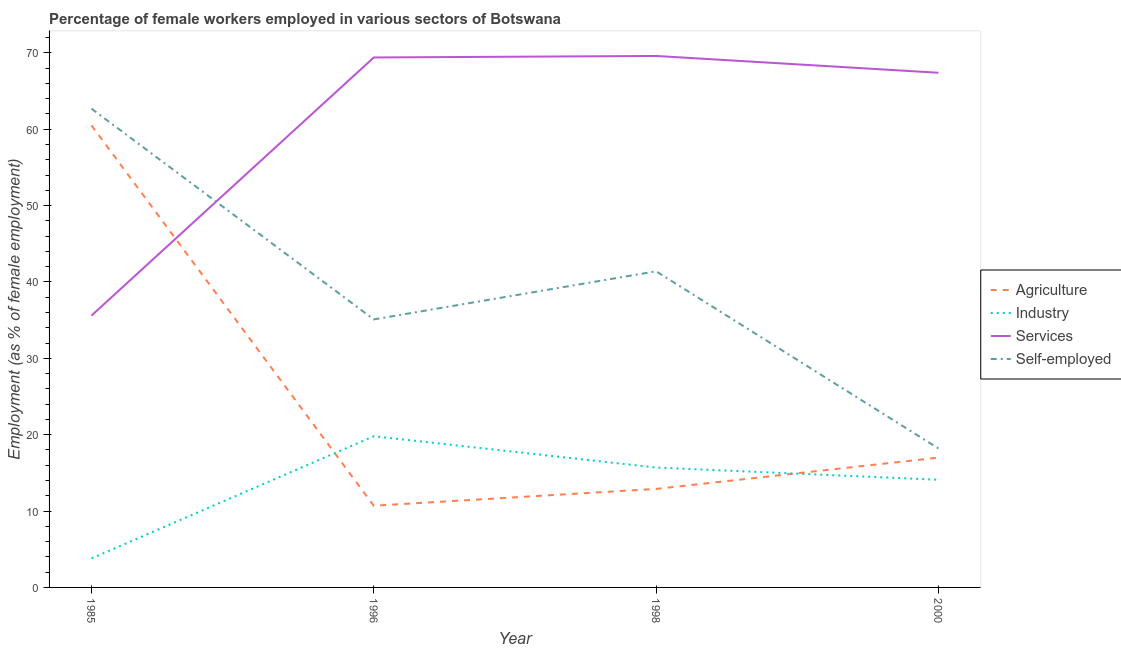Across all years, what is the maximum percentage of female workers in services?
Provide a short and direct response. 69.6. Across all years, what is the minimum percentage of female workers in agriculture?
Your answer should be compact. 10.7. In which year was the percentage of self employed female workers minimum?
Ensure brevity in your answer.  2000. What is the total percentage of female workers in industry in the graph?
Your answer should be very brief. 53.4. What is the difference between the percentage of female workers in industry in 1985 and that in 1996?
Provide a succinct answer. -16. What is the difference between the percentage of female workers in agriculture in 2000 and the percentage of self employed female workers in 1998?
Make the answer very short. -24.4. What is the average percentage of female workers in industry per year?
Your answer should be compact. 13.35. In the year 1985, what is the difference between the percentage of female workers in agriculture and percentage of female workers in industry?
Give a very brief answer. 56.7. What is the ratio of the percentage of female workers in services in 1996 to that in 1998?
Give a very brief answer. 1. Is the percentage of self employed female workers in 1998 less than that in 2000?
Provide a short and direct response. No. What is the difference between the highest and the second highest percentage of female workers in services?
Provide a succinct answer. 0.2. What is the difference between the highest and the lowest percentage of self employed female workers?
Offer a very short reply. 44.5. In how many years, is the percentage of self employed female workers greater than the average percentage of self employed female workers taken over all years?
Your response must be concise. 2. Is the sum of the percentage of female workers in services in 1985 and 2000 greater than the maximum percentage of female workers in agriculture across all years?
Make the answer very short. Yes. Is it the case that in every year, the sum of the percentage of female workers in industry and percentage of female workers in agriculture is greater than the sum of percentage of female workers in services and percentage of self employed female workers?
Offer a very short reply. No. Is it the case that in every year, the sum of the percentage of female workers in agriculture and percentage of female workers in industry is greater than the percentage of female workers in services?
Offer a very short reply. No. Does the percentage of female workers in industry monotonically increase over the years?
Keep it short and to the point. No. Is the percentage of female workers in services strictly greater than the percentage of self employed female workers over the years?
Offer a very short reply. No. How many lines are there?
Your response must be concise. 4. How many years are there in the graph?
Keep it short and to the point. 4. What is the difference between two consecutive major ticks on the Y-axis?
Provide a short and direct response. 10. Are the values on the major ticks of Y-axis written in scientific E-notation?
Ensure brevity in your answer.  No. Does the graph contain any zero values?
Give a very brief answer. No. Does the graph contain grids?
Make the answer very short. No. Where does the legend appear in the graph?
Provide a short and direct response. Center right. What is the title of the graph?
Offer a terse response. Percentage of female workers employed in various sectors of Botswana. Does "Payroll services" appear as one of the legend labels in the graph?
Give a very brief answer. No. What is the label or title of the X-axis?
Your answer should be compact. Year. What is the label or title of the Y-axis?
Provide a succinct answer. Employment (as % of female employment). What is the Employment (as % of female employment) of Agriculture in 1985?
Provide a succinct answer. 60.5. What is the Employment (as % of female employment) in Industry in 1985?
Give a very brief answer. 3.8. What is the Employment (as % of female employment) of Services in 1985?
Ensure brevity in your answer.  35.6. What is the Employment (as % of female employment) of Self-employed in 1985?
Provide a succinct answer. 62.7. What is the Employment (as % of female employment) of Agriculture in 1996?
Give a very brief answer. 10.7. What is the Employment (as % of female employment) of Industry in 1996?
Keep it short and to the point. 19.8. What is the Employment (as % of female employment) in Services in 1996?
Give a very brief answer. 69.4. What is the Employment (as % of female employment) in Self-employed in 1996?
Give a very brief answer. 35.1. What is the Employment (as % of female employment) in Agriculture in 1998?
Make the answer very short. 12.9. What is the Employment (as % of female employment) in Industry in 1998?
Keep it short and to the point. 15.7. What is the Employment (as % of female employment) of Services in 1998?
Give a very brief answer. 69.6. What is the Employment (as % of female employment) of Self-employed in 1998?
Your response must be concise. 41.4. What is the Employment (as % of female employment) of Industry in 2000?
Ensure brevity in your answer.  14.1. What is the Employment (as % of female employment) of Services in 2000?
Offer a terse response. 67.4. What is the Employment (as % of female employment) in Self-employed in 2000?
Offer a very short reply. 18.2. Across all years, what is the maximum Employment (as % of female employment) in Agriculture?
Your answer should be very brief. 60.5. Across all years, what is the maximum Employment (as % of female employment) of Industry?
Make the answer very short. 19.8. Across all years, what is the maximum Employment (as % of female employment) of Services?
Your response must be concise. 69.6. Across all years, what is the maximum Employment (as % of female employment) of Self-employed?
Provide a succinct answer. 62.7. Across all years, what is the minimum Employment (as % of female employment) of Agriculture?
Offer a very short reply. 10.7. Across all years, what is the minimum Employment (as % of female employment) of Industry?
Offer a terse response. 3.8. Across all years, what is the minimum Employment (as % of female employment) in Services?
Ensure brevity in your answer.  35.6. Across all years, what is the minimum Employment (as % of female employment) of Self-employed?
Provide a short and direct response. 18.2. What is the total Employment (as % of female employment) of Agriculture in the graph?
Your answer should be very brief. 101.1. What is the total Employment (as % of female employment) in Industry in the graph?
Make the answer very short. 53.4. What is the total Employment (as % of female employment) in Services in the graph?
Offer a very short reply. 242. What is the total Employment (as % of female employment) in Self-employed in the graph?
Your response must be concise. 157.4. What is the difference between the Employment (as % of female employment) in Agriculture in 1985 and that in 1996?
Make the answer very short. 49.8. What is the difference between the Employment (as % of female employment) of Services in 1985 and that in 1996?
Provide a short and direct response. -33.8. What is the difference between the Employment (as % of female employment) of Self-employed in 1985 and that in 1996?
Give a very brief answer. 27.6. What is the difference between the Employment (as % of female employment) of Agriculture in 1985 and that in 1998?
Offer a terse response. 47.6. What is the difference between the Employment (as % of female employment) of Services in 1985 and that in 1998?
Your response must be concise. -34. What is the difference between the Employment (as % of female employment) of Self-employed in 1985 and that in 1998?
Offer a terse response. 21.3. What is the difference between the Employment (as % of female employment) in Agriculture in 1985 and that in 2000?
Provide a short and direct response. 43.5. What is the difference between the Employment (as % of female employment) of Services in 1985 and that in 2000?
Your answer should be compact. -31.8. What is the difference between the Employment (as % of female employment) of Self-employed in 1985 and that in 2000?
Offer a terse response. 44.5. What is the difference between the Employment (as % of female employment) in Agriculture in 1996 and that in 1998?
Offer a terse response. -2.2. What is the difference between the Employment (as % of female employment) in Self-employed in 1996 and that in 1998?
Offer a very short reply. -6.3. What is the difference between the Employment (as % of female employment) in Agriculture in 1996 and that in 2000?
Offer a very short reply. -6.3. What is the difference between the Employment (as % of female employment) in Industry in 1996 and that in 2000?
Your answer should be compact. 5.7. What is the difference between the Employment (as % of female employment) of Services in 1998 and that in 2000?
Provide a succinct answer. 2.2. What is the difference between the Employment (as % of female employment) of Self-employed in 1998 and that in 2000?
Give a very brief answer. 23.2. What is the difference between the Employment (as % of female employment) of Agriculture in 1985 and the Employment (as % of female employment) of Industry in 1996?
Make the answer very short. 40.7. What is the difference between the Employment (as % of female employment) in Agriculture in 1985 and the Employment (as % of female employment) in Services in 1996?
Offer a terse response. -8.9. What is the difference between the Employment (as % of female employment) of Agriculture in 1985 and the Employment (as % of female employment) of Self-employed in 1996?
Give a very brief answer. 25.4. What is the difference between the Employment (as % of female employment) of Industry in 1985 and the Employment (as % of female employment) of Services in 1996?
Your response must be concise. -65.6. What is the difference between the Employment (as % of female employment) in Industry in 1985 and the Employment (as % of female employment) in Self-employed in 1996?
Your answer should be very brief. -31.3. What is the difference between the Employment (as % of female employment) in Services in 1985 and the Employment (as % of female employment) in Self-employed in 1996?
Give a very brief answer. 0.5. What is the difference between the Employment (as % of female employment) in Agriculture in 1985 and the Employment (as % of female employment) in Industry in 1998?
Ensure brevity in your answer.  44.8. What is the difference between the Employment (as % of female employment) in Agriculture in 1985 and the Employment (as % of female employment) in Services in 1998?
Offer a terse response. -9.1. What is the difference between the Employment (as % of female employment) in Agriculture in 1985 and the Employment (as % of female employment) in Self-employed in 1998?
Give a very brief answer. 19.1. What is the difference between the Employment (as % of female employment) in Industry in 1985 and the Employment (as % of female employment) in Services in 1998?
Provide a succinct answer. -65.8. What is the difference between the Employment (as % of female employment) of Industry in 1985 and the Employment (as % of female employment) of Self-employed in 1998?
Provide a short and direct response. -37.6. What is the difference between the Employment (as % of female employment) in Services in 1985 and the Employment (as % of female employment) in Self-employed in 1998?
Offer a very short reply. -5.8. What is the difference between the Employment (as % of female employment) of Agriculture in 1985 and the Employment (as % of female employment) of Industry in 2000?
Offer a very short reply. 46.4. What is the difference between the Employment (as % of female employment) of Agriculture in 1985 and the Employment (as % of female employment) of Self-employed in 2000?
Keep it short and to the point. 42.3. What is the difference between the Employment (as % of female employment) in Industry in 1985 and the Employment (as % of female employment) in Services in 2000?
Keep it short and to the point. -63.6. What is the difference between the Employment (as % of female employment) of Industry in 1985 and the Employment (as % of female employment) of Self-employed in 2000?
Give a very brief answer. -14.4. What is the difference between the Employment (as % of female employment) in Services in 1985 and the Employment (as % of female employment) in Self-employed in 2000?
Provide a short and direct response. 17.4. What is the difference between the Employment (as % of female employment) of Agriculture in 1996 and the Employment (as % of female employment) of Industry in 1998?
Give a very brief answer. -5. What is the difference between the Employment (as % of female employment) in Agriculture in 1996 and the Employment (as % of female employment) in Services in 1998?
Provide a short and direct response. -58.9. What is the difference between the Employment (as % of female employment) in Agriculture in 1996 and the Employment (as % of female employment) in Self-employed in 1998?
Make the answer very short. -30.7. What is the difference between the Employment (as % of female employment) in Industry in 1996 and the Employment (as % of female employment) in Services in 1998?
Offer a terse response. -49.8. What is the difference between the Employment (as % of female employment) of Industry in 1996 and the Employment (as % of female employment) of Self-employed in 1998?
Provide a succinct answer. -21.6. What is the difference between the Employment (as % of female employment) in Services in 1996 and the Employment (as % of female employment) in Self-employed in 1998?
Your answer should be compact. 28. What is the difference between the Employment (as % of female employment) in Agriculture in 1996 and the Employment (as % of female employment) in Services in 2000?
Provide a succinct answer. -56.7. What is the difference between the Employment (as % of female employment) of Industry in 1996 and the Employment (as % of female employment) of Services in 2000?
Ensure brevity in your answer.  -47.6. What is the difference between the Employment (as % of female employment) in Industry in 1996 and the Employment (as % of female employment) in Self-employed in 2000?
Offer a very short reply. 1.6. What is the difference between the Employment (as % of female employment) of Services in 1996 and the Employment (as % of female employment) of Self-employed in 2000?
Your answer should be very brief. 51.2. What is the difference between the Employment (as % of female employment) in Agriculture in 1998 and the Employment (as % of female employment) in Services in 2000?
Make the answer very short. -54.5. What is the difference between the Employment (as % of female employment) in Industry in 1998 and the Employment (as % of female employment) in Services in 2000?
Your answer should be compact. -51.7. What is the difference between the Employment (as % of female employment) in Services in 1998 and the Employment (as % of female employment) in Self-employed in 2000?
Make the answer very short. 51.4. What is the average Employment (as % of female employment) of Agriculture per year?
Make the answer very short. 25.27. What is the average Employment (as % of female employment) of Industry per year?
Ensure brevity in your answer.  13.35. What is the average Employment (as % of female employment) of Services per year?
Ensure brevity in your answer.  60.5. What is the average Employment (as % of female employment) of Self-employed per year?
Provide a succinct answer. 39.35. In the year 1985, what is the difference between the Employment (as % of female employment) in Agriculture and Employment (as % of female employment) in Industry?
Offer a very short reply. 56.7. In the year 1985, what is the difference between the Employment (as % of female employment) in Agriculture and Employment (as % of female employment) in Services?
Offer a very short reply. 24.9. In the year 1985, what is the difference between the Employment (as % of female employment) of Industry and Employment (as % of female employment) of Services?
Offer a very short reply. -31.8. In the year 1985, what is the difference between the Employment (as % of female employment) of Industry and Employment (as % of female employment) of Self-employed?
Offer a very short reply. -58.9. In the year 1985, what is the difference between the Employment (as % of female employment) of Services and Employment (as % of female employment) of Self-employed?
Offer a terse response. -27.1. In the year 1996, what is the difference between the Employment (as % of female employment) of Agriculture and Employment (as % of female employment) of Industry?
Provide a succinct answer. -9.1. In the year 1996, what is the difference between the Employment (as % of female employment) of Agriculture and Employment (as % of female employment) of Services?
Your response must be concise. -58.7. In the year 1996, what is the difference between the Employment (as % of female employment) in Agriculture and Employment (as % of female employment) in Self-employed?
Your response must be concise. -24.4. In the year 1996, what is the difference between the Employment (as % of female employment) in Industry and Employment (as % of female employment) in Services?
Offer a very short reply. -49.6. In the year 1996, what is the difference between the Employment (as % of female employment) in Industry and Employment (as % of female employment) in Self-employed?
Your response must be concise. -15.3. In the year 1996, what is the difference between the Employment (as % of female employment) in Services and Employment (as % of female employment) in Self-employed?
Offer a very short reply. 34.3. In the year 1998, what is the difference between the Employment (as % of female employment) in Agriculture and Employment (as % of female employment) in Industry?
Give a very brief answer. -2.8. In the year 1998, what is the difference between the Employment (as % of female employment) of Agriculture and Employment (as % of female employment) of Services?
Offer a very short reply. -56.7. In the year 1998, what is the difference between the Employment (as % of female employment) in Agriculture and Employment (as % of female employment) in Self-employed?
Ensure brevity in your answer.  -28.5. In the year 1998, what is the difference between the Employment (as % of female employment) of Industry and Employment (as % of female employment) of Services?
Give a very brief answer. -53.9. In the year 1998, what is the difference between the Employment (as % of female employment) of Industry and Employment (as % of female employment) of Self-employed?
Your answer should be compact. -25.7. In the year 1998, what is the difference between the Employment (as % of female employment) in Services and Employment (as % of female employment) in Self-employed?
Ensure brevity in your answer.  28.2. In the year 2000, what is the difference between the Employment (as % of female employment) in Agriculture and Employment (as % of female employment) in Industry?
Provide a short and direct response. 2.9. In the year 2000, what is the difference between the Employment (as % of female employment) of Agriculture and Employment (as % of female employment) of Services?
Your response must be concise. -50.4. In the year 2000, what is the difference between the Employment (as % of female employment) in Industry and Employment (as % of female employment) in Services?
Offer a terse response. -53.3. In the year 2000, what is the difference between the Employment (as % of female employment) in Services and Employment (as % of female employment) in Self-employed?
Your answer should be very brief. 49.2. What is the ratio of the Employment (as % of female employment) of Agriculture in 1985 to that in 1996?
Offer a terse response. 5.65. What is the ratio of the Employment (as % of female employment) in Industry in 1985 to that in 1996?
Ensure brevity in your answer.  0.19. What is the ratio of the Employment (as % of female employment) in Services in 1985 to that in 1996?
Keep it short and to the point. 0.51. What is the ratio of the Employment (as % of female employment) in Self-employed in 1985 to that in 1996?
Ensure brevity in your answer.  1.79. What is the ratio of the Employment (as % of female employment) of Agriculture in 1985 to that in 1998?
Give a very brief answer. 4.69. What is the ratio of the Employment (as % of female employment) in Industry in 1985 to that in 1998?
Offer a very short reply. 0.24. What is the ratio of the Employment (as % of female employment) of Services in 1985 to that in 1998?
Provide a short and direct response. 0.51. What is the ratio of the Employment (as % of female employment) of Self-employed in 1985 to that in 1998?
Give a very brief answer. 1.51. What is the ratio of the Employment (as % of female employment) in Agriculture in 1985 to that in 2000?
Your answer should be compact. 3.56. What is the ratio of the Employment (as % of female employment) in Industry in 1985 to that in 2000?
Ensure brevity in your answer.  0.27. What is the ratio of the Employment (as % of female employment) in Services in 1985 to that in 2000?
Offer a terse response. 0.53. What is the ratio of the Employment (as % of female employment) in Self-employed in 1985 to that in 2000?
Ensure brevity in your answer.  3.45. What is the ratio of the Employment (as % of female employment) of Agriculture in 1996 to that in 1998?
Make the answer very short. 0.83. What is the ratio of the Employment (as % of female employment) of Industry in 1996 to that in 1998?
Offer a very short reply. 1.26. What is the ratio of the Employment (as % of female employment) of Self-employed in 1996 to that in 1998?
Your response must be concise. 0.85. What is the ratio of the Employment (as % of female employment) in Agriculture in 1996 to that in 2000?
Make the answer very short. 0.63. What is the ratio of the Employment (as % of female employment) in Industry in 1996 to that in 2000?
Your answer should be compact. 1.4. What is the ratio of the Employment (as % of female employment) in Services in 1996 to that in 2000?
Offer a terse response. 1.03. What is the ratio of the Employment (as % of female employment) of Self-employed in 1996 to that in 2000?
Provide a short and direct response. 1.93. What is the ratio of the Employment (as % of female employment) in Agriculture in 1998 to that in 2000?
Your answer should be very brief. 0.76. What is the ratio of the Employment (as % of female employment) of Industry in 1998 to that in 2000?
Provide a succinct answer. 1.11. What is the ratio of the Employment (as % of female employment) of Services in 1998 to that in 2000?
Offer a very short reply. 1.03. What is the ratio of the Employment (as % of female employment) in Self-employed in 1998 to that in 2000?
Keep it short and to the point. 2.27. What is the difference between the highest and the second highest Employment (as % of female employment) in Agriculture?
Give a very brief answer. 43.5. What is the difference between the highest and the second highest Employment (as % of female employment) of Services?
Offer a very short reply. 0.2. What is the difference between the highest and the second highest Employment (as % of female employment) in Self-employed?
Your answer should be compact. 21.3. What is the difference between the highest and the lowest Employment (as % of female employment) in Agriculture?
Your answer should be very brief. 49.8. What is the difference between the highest and the lowest Employment (as % of female employment) of Industry?
Provide a succinct answer. 16. What is the difference between the highest and the lowest Employment (as % of female employment) in Services?
Your answer should be very brief. 34. What is the difference between the highest and the lowest Employment (as % of female employment) in Self-employed?
Keep it short and to the point. 44.5. 